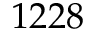<formula> <loc_0><loc_0><loc_500><loc_500>1 2 2 8</formula> 